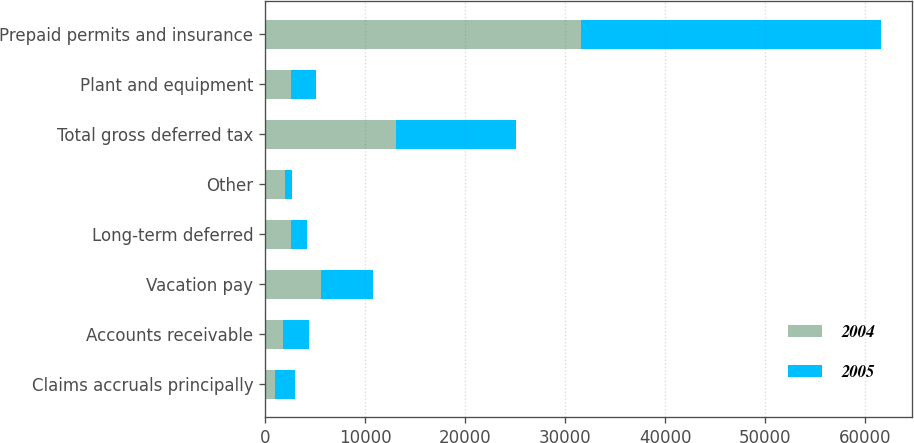Convert chart to OTSL. <chart><loc_0><loc_0><loc_500><loc_500><stacked_bar_chart><ecel><fcel>Claims accruals principally<fcel>Accounts receivable<fcel>Vacation pay<fcel>Long-term deferred<fcel>Other<fcel>Total gross deferred tax<fcel>Plant and equipment<fcel>Prepaid permits and insurance<nl><fcel>2004<fcel>1023<fcel>1831<fcel>5627<fcel>2558<fcel>2042<fcel>13081<fcel>2549.5<fcel>31582<nl><fcel>2005<fcel>1987<fcel>2541<fcel>5139<fcel>1614<fcel>678<fcel>11959<fcel>2549.5<fcel>29963<nl></chart> 